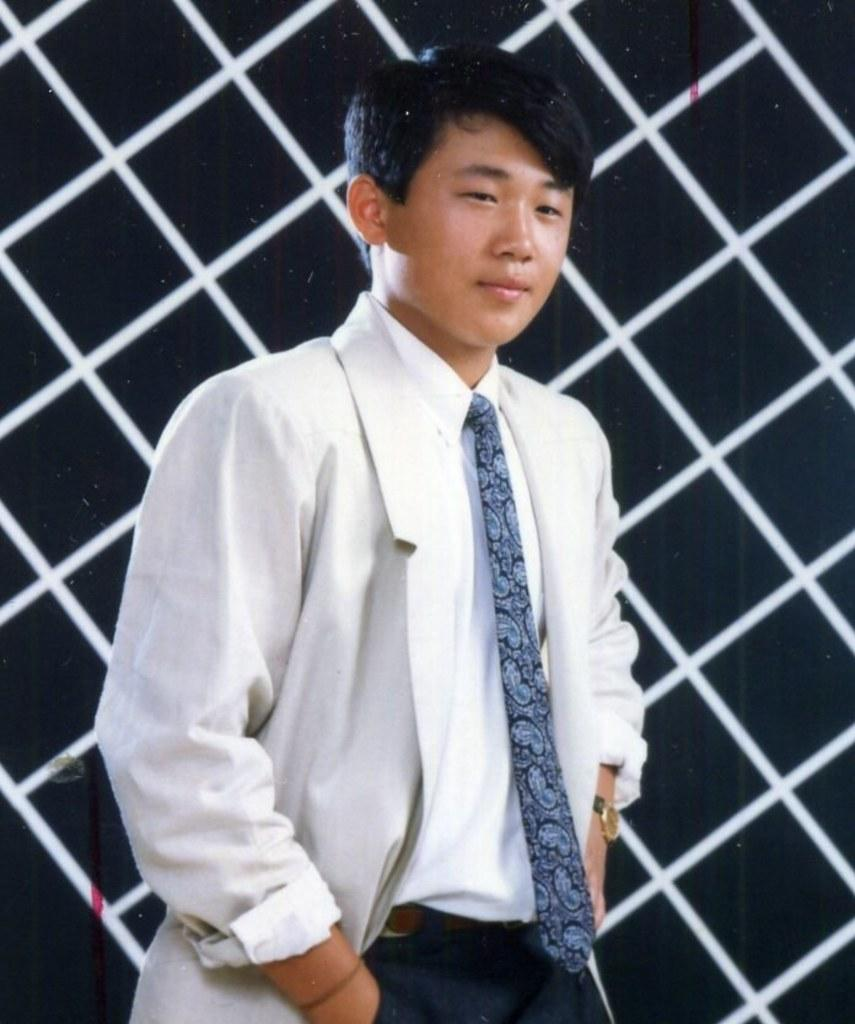Who or what is the main subject in the image? There is a person in the center of the image. What is the person wearing? The person is wearing a coat and a tie. What is the person's posture in the image? The person is standing. What can be seen in the background of the image? There is a wall in the background of the image. What type of stone is the person holding in their hands in the image? There is no stone or any object being held in the person's hands in the image. What color is the spot on the person's coat in the image? There is no spot visible on the person's coat in the image. 